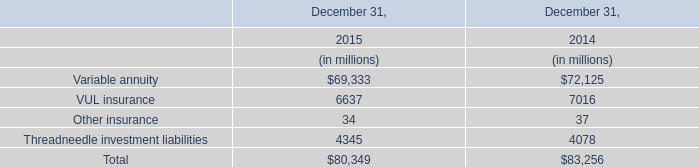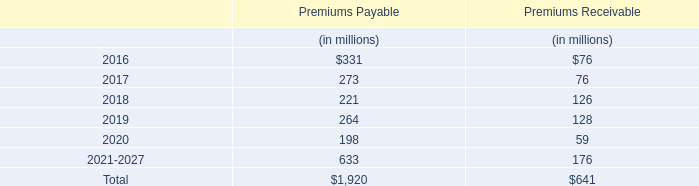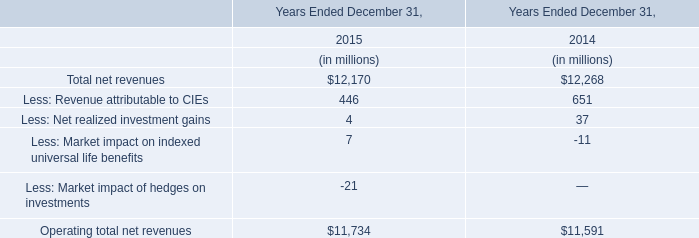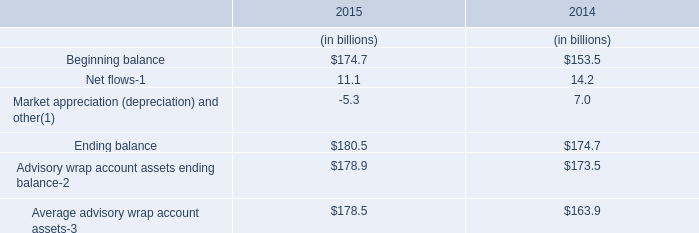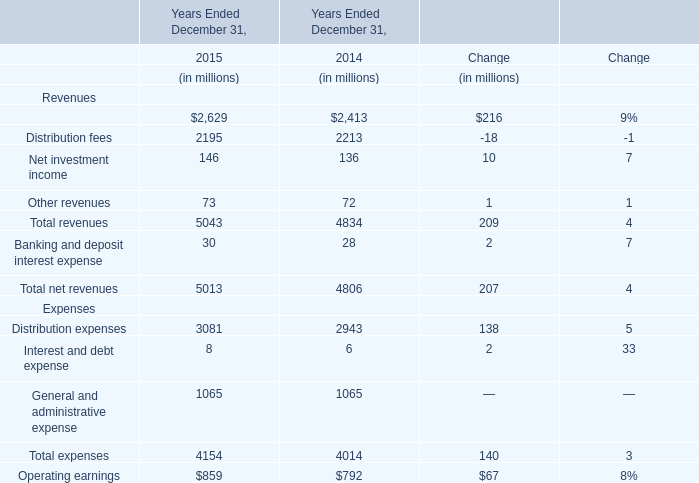In the year with largest amount of Beginning balance, what's the increasing rate of Ending balance? 
Computations: ((180.5 - 174.7) / 174.7)
Answer: 0.0332. 